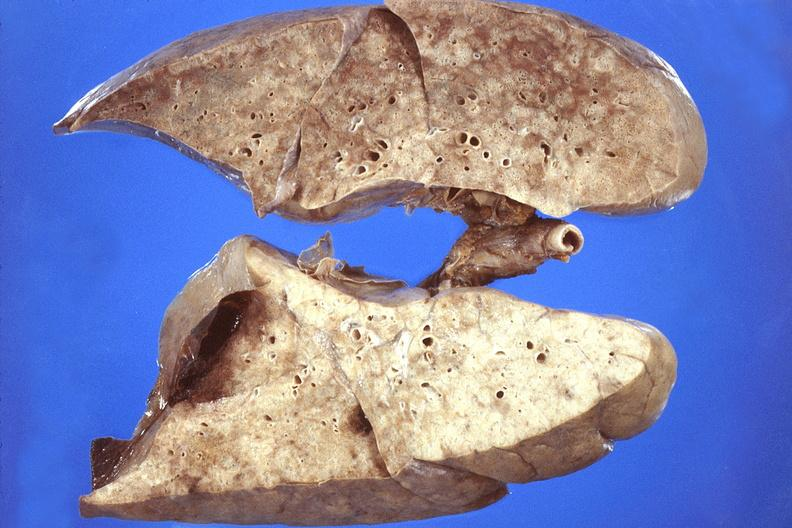does this image show lung, pneumocystis pneumonia?
Answer the question using a single word or phrase. Yes 